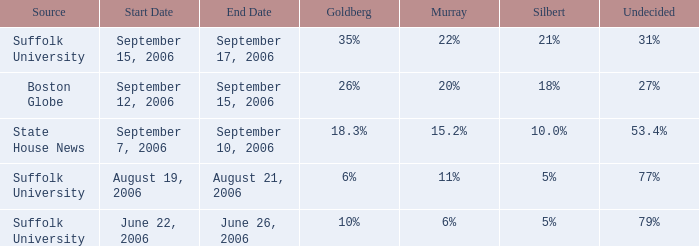What is the date of the poll with Goldberg at 26%? September 12–15, 2006. Could you parse the entire table? {'header': ['Source', 'Start Date', 'End Date', 'Goldberg', 'Murray', 'Silbert', 'Undecided'], 'rows': [['Suffolk University', 'September 15, 2006', 'September 17, 2006', '35%', '22%', '21%', '31%'], ['Boston Globe', 'September 12, 2006', 'September 15, 2006', '26%', '20%', '18%', '27%'], ['State House News', 'September 7, 2006', 'September 10, 2006', '18.3%', '15.2%', '10.0%', '53.4%'], ['Suffolk University', 'August 19, 2006', 'August 21, 2006', '6%', '11%', '5%', '77%'], ['Suffolk University', 'June 22, 2006', 'June 26, 2006', '10%', '6%', '5%', '79%']]} 